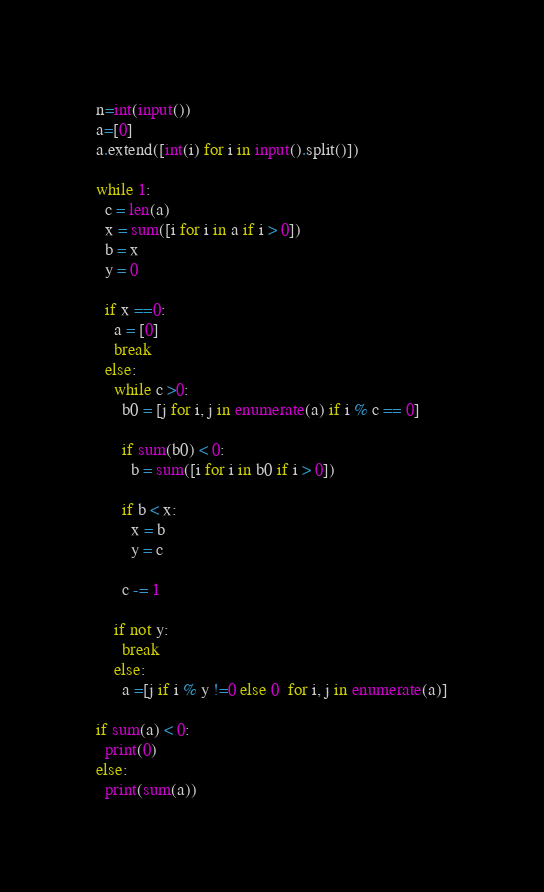<code> <loc_0><loc_0><loc_500><loc_500><_Python_>n=int(input())
a=[0]
a.extend([int(i) for i in input().split()])

while 1:
  c = len(a)
  x = sum([i for i in a if i > 0])
  b = x
  y = 0
  
  if x ==0:
    a = [0]
    break
  else:
    while c >0:
      b0 = [j for i, j in enumerate(a) if i % c == 0]

      if sum(b0) < 0:
        b = sum([i for i in b0 if i > 0])

      if b < x:
        x = b
        y = c

      c -= 1

    if not y:
      break
    else:
      a =[j if i % y !=0 else 0  for i, j in enumerate(a)]

if sum(a) < 0:
  print(0)    
else:
  print(sum(a))</code> 